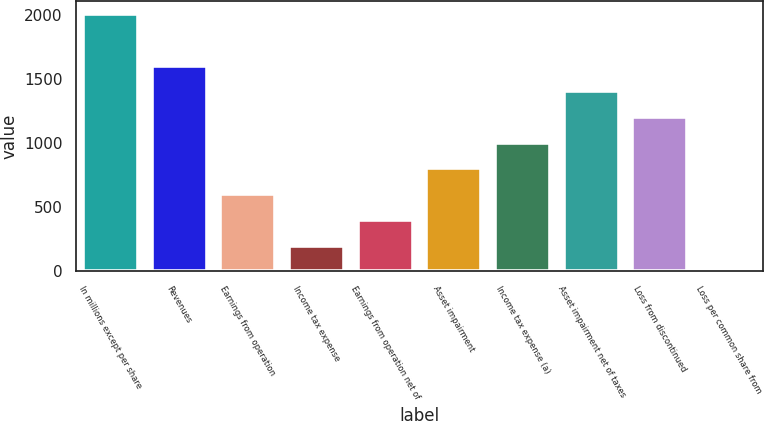Convert chart. <chart><loc_0><loc_0><loc_500><loc_500><bar_chart><fcel>In millions except per share<fcel>Revenues<fcel>Earnings from operation<fcel>Income tax expense<fcel>Earnings from operation net of<fcel>Asset impairment<fcel>Income tax expense (a)<fcel>Asset impairment net of taxes<fcel>Loss from discontinued<fcel>Loss per common share from<nl><fcel>2004<fcel>1603.47<fcel>602.09<fcel>201.53<fcel>401.81<fcel>802.37<fcel>1002.64<fcel>1403.19<fcel>1202.91<fcel>1.25<nl></chart> 